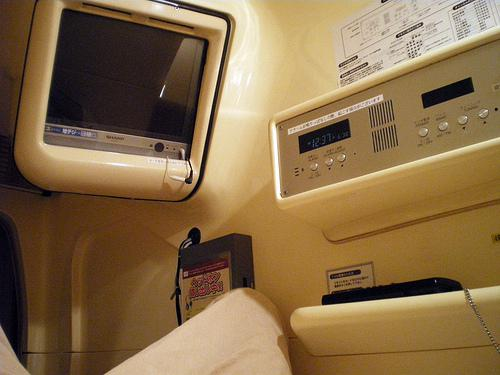Question: what is on the wall?
Choices:
A. Television.
B. Clock.
C. Monitor.
D. Diploma.
Answer with the letter. Answer: C 